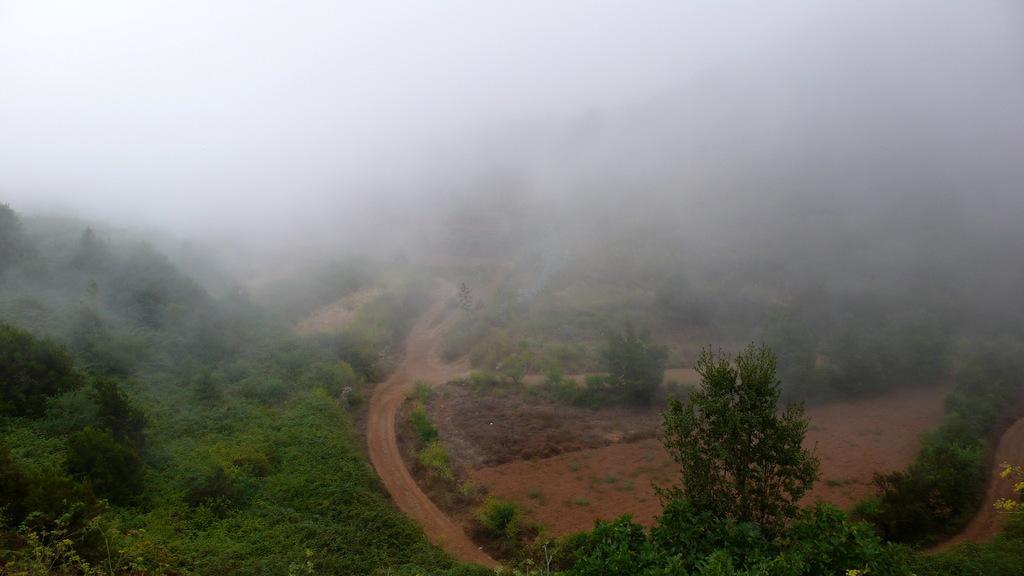Describe this image in one or two sentences. There is a road, near plants and trees on the hill. On the right side, there are trees and plants near a dry land. In the background, there is snow smoke. 